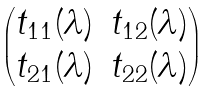Convert formula to latex. <formula><loc_0><loc_0><loc_500><loc_500>\begin{pmatrix} t _ { 1 1 } ( \lambda ) & t _ { 1 2 } ( \lambda ) \\ t _ { 2 1 } ( \lambda ) & t _ { 2 2 } ( \lambda ) \\ \end{pmatrix}</formula> 